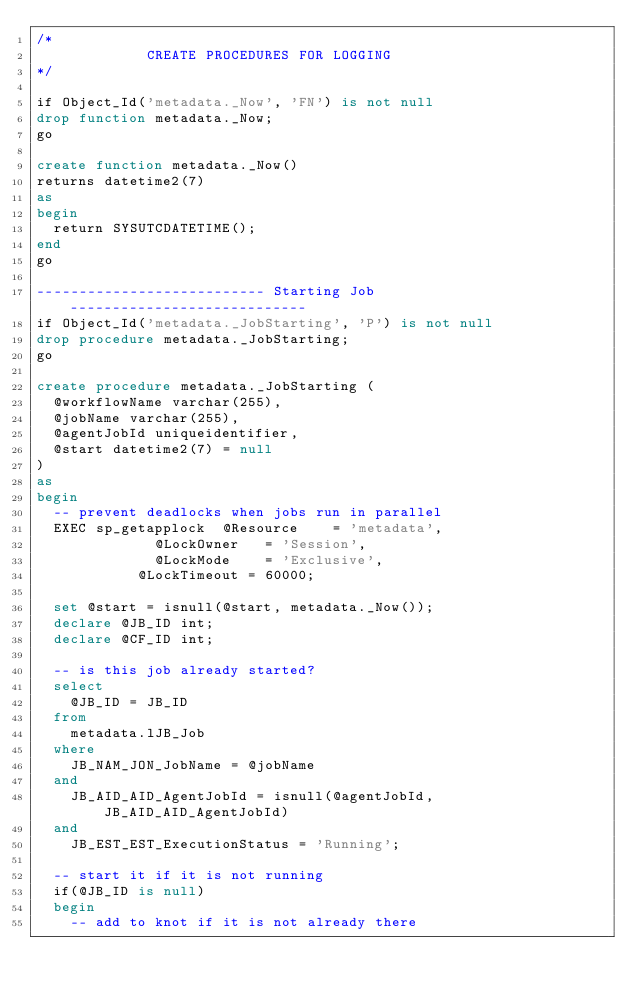Convert code to text. <code><loc_0><loc_0><loc_500><loc_500><_SQL_>/*
             CREATE PROCEDURES FOR LOGGING
*/

if Object_Id('metadata._Now', 'FN') is not null
drop function metadata._Now;
go

create function metadata._Now()
returns datetime2(7)
as
begin
	return SYSUTCDATETIME();
end
go

--------------------------- Starting Job ----------------------------
if Object_Id('metadata._JobStarting', 'P') is not null
drop procedure metadata._JobStarting;
go

create procedure metadata._JobStarting (
	@workflowName varchar(255),
	@jobName varchar(255),
	@agentJobId uniqueidentifier,
	@start datetime2(7) = null
)
as
begin
	-- prevent deadlocks when jobs run in parallel
	EXEC sp_getapplock 	@Resource    = 'metadata',  
     					@LockOwner   = 'Session',
     					@LockMode    = 'Exclusive',
						@LockTimeout = 60000;

	set @start = isnull(@start, metadata._Now());
	declare @JB_ID int;
	declare @CF_ID int;

	-- is this job already started?
	select
		@JB_ID = JB_ID
	from
		metadata.lJB_Job
	where
		JB_NAM_JON_JobName = @jobName
	and
		JB_AID_AID_AgentJobId = isnull(@agentJobId, JB_AID_AID_AgentJobId)
	and
		JB_EST_EST_ExecutionStatus = 'Running';

	-- start it if it is not running
	if(@JB_ID is null)
	begin
		-- add to knot if it is not already there</code> 